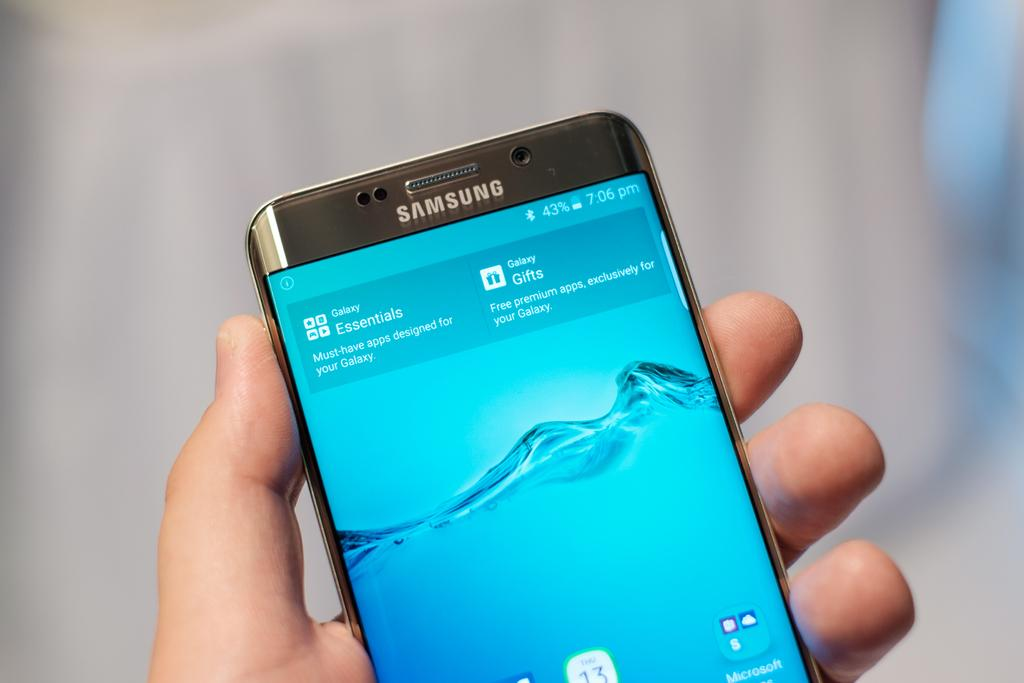What is the main subject of the image? There is a person in the image. What is the person holding in their hand? The person is holding a mobile phone in one of their hands. What type of alarm can be heard in the image? There is no alarm present in the image; it only shows a person holding a mobile phone. What emotional response can be seen from the person in the image? The image does not show any emotional response from the person, as it only shows them holding a mobile phone. 